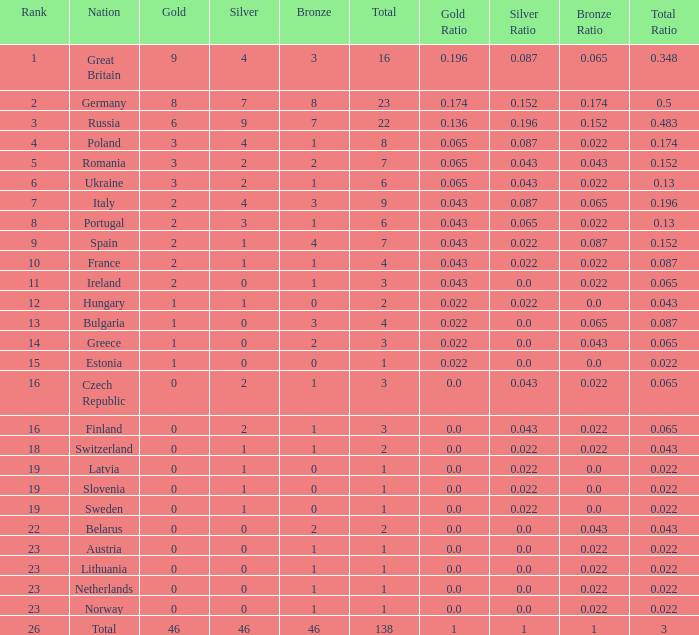What is the total number for a total when the nation is netherlands and silver is larger than 0? 0.0. 